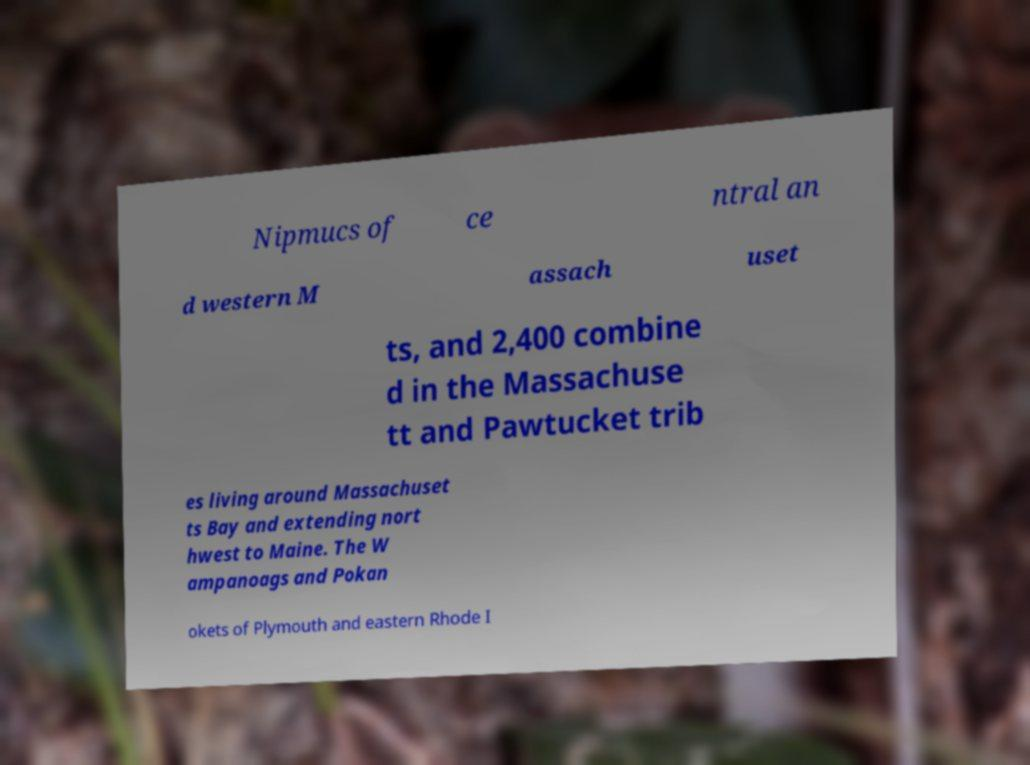I need the written content from this picture converted into text. Can you do that? Nipmucs of ce ntral an d western M assach uset ts, and 2,400 combine d in the Massachuse tt and Pawtucket trib es living around Massachuset ts Bay and extending nort hwest to Maine. The W ampanoags and Pokan okets of Plymouth and eastern Rhode I 